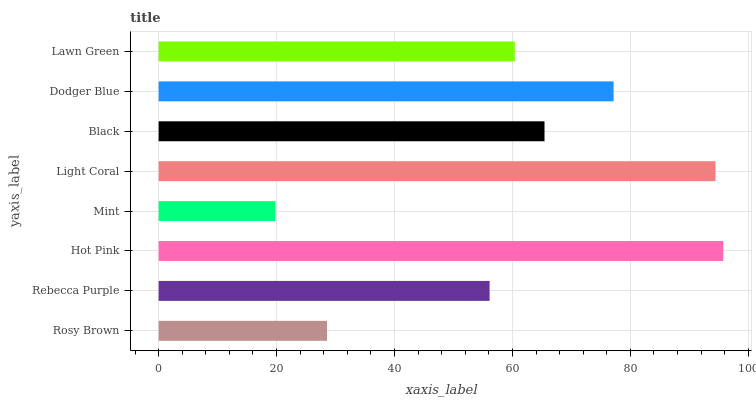Is Mint the minimum?
Answer yes or no. Yes. Is Hot Pink the maximum?
Answer yes or no. Yes. Is Rebecca Purple the minimum?
Answer yes or no. No. Is Rebecca Purple the maximum?
Answer yes or no. No. Is Rebecca Purple greater than Rosy Brown?
Answer yes or no. Yes. Is Rosy Brown less than Rebecca Purple?
Answer yes or no. Yes. Is Rosy Brown greater than Rebecca Purple?
Answer yes or no. No. Is Rebecca Purple less than Rosy Brown?
Answer yes or no. No. Is Black the high median?
Answer yes or no. Yes. Is Lawn Green the low median?
Answer yes or no. Yes. Is Dodger Blue the high median?
Answer yes or no. No. Is Black the low median?
Answer yes or no. No. 